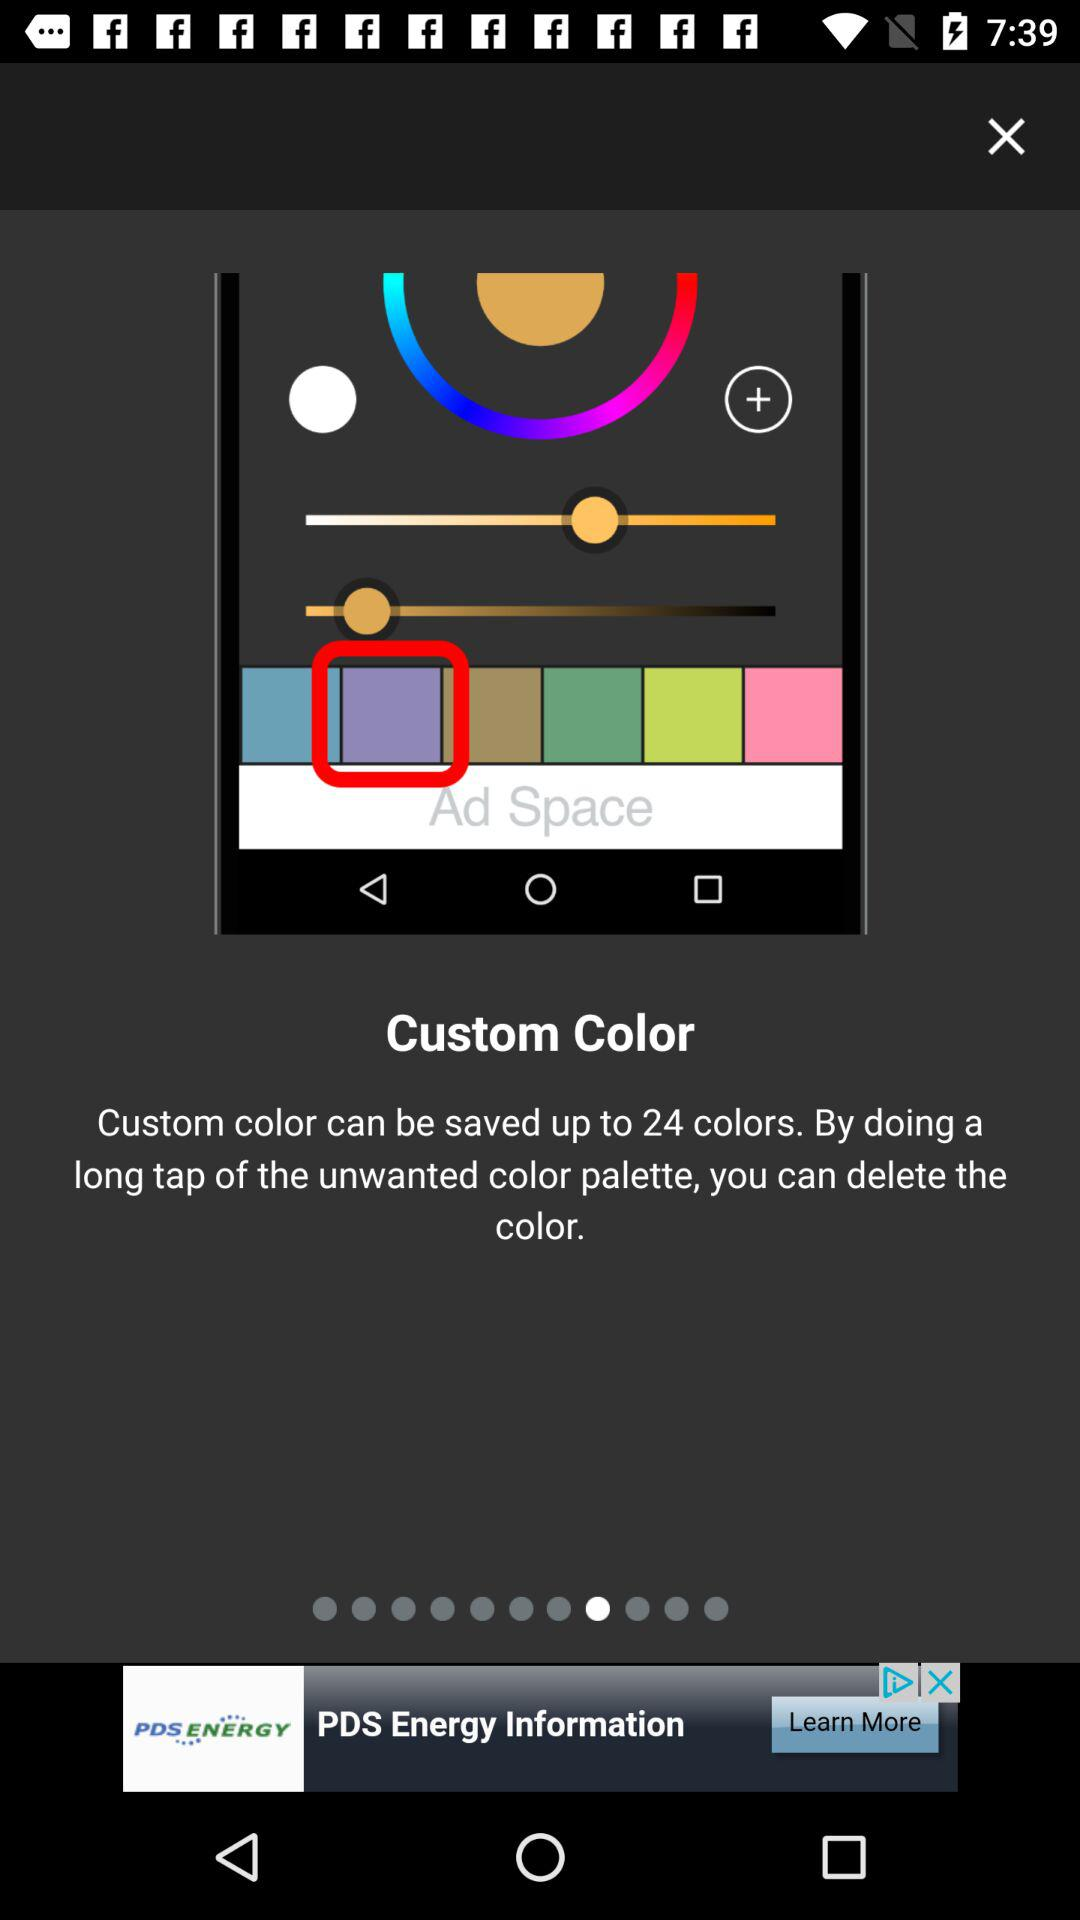How many colors can be saved as custom colors? As custom colors, 24 colors can be saved. 